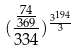Convert formula to latex. <formula><loc_0><loc_0><loc_500><loc_500>( \frac { \frac { 7 4 } { 3 6 9 } } { 3 3 4 } ) ^ { \frac { 3 ^ { 1 9 4 } } { 3 } }</formula> 